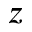<formula> <loc_0><loc_0><loc_500><loc_500>z</formula> 